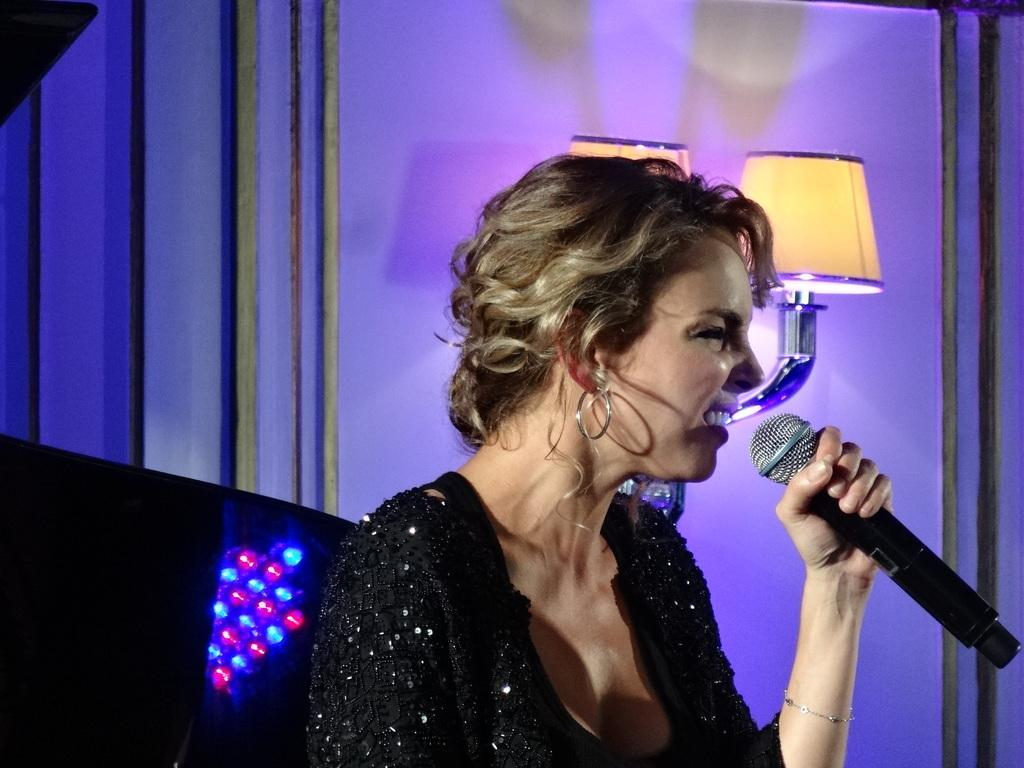Who is the main subject in the picture? There is a woman in the picture. What is the woman doing in the image? The woman is sitting. What object is the woman holding in the picture? The woman is holding a microphone (mike). What type of spark can be seen coming from the microphone in the image? There is no spark coming from the microphone in the image. Is the woman in the image a spy? There is no indication in the image that the woman is a spy. 